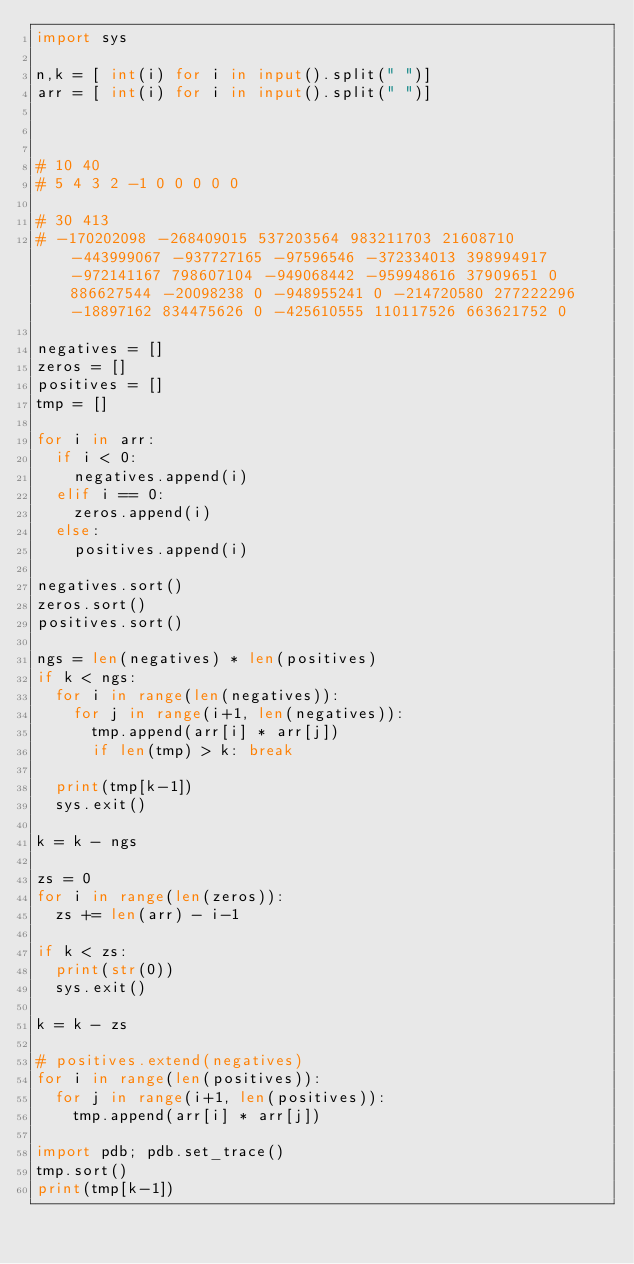Convert code to text. <code><loc_0><loc_0><loc_500><loc_500><_Python_>import sys

n,k = [ int(i) for i in input().split(" ")]
arr = [ int(i) for i in input().split(" ")]



# 10 40
# 5 4 3 2 -1 0 0 0 0 0

# 30 413
# -170202098 -268409015 537203564 983211703 21608710 -443999067 -937727165 -97596546 -372334013 398994917 -972141167 798607104 -949068442 -959948616 37909651 0 886627544 -20098238 0 -948955241 0 -214720580 277222296 -18897162 834475626 0 -425610555 110117526 663621752 0

negatives = []
zeros = []
positives = []
tmp = []

for i in arr:
  if i < 0:
    negatives.append(i)
  elif i == 0:
    zeros.append(i)
  else:
    positives.append(i)

negatives.sort()
zeros.sort()
positives.sort()

ngs = len(negatives) * len(positives)
if k < ngs:
  for i in range(len(negatives)):
    for j in range(i+1, len(negatives)):
      tmp.append(arr[i] * arr[j])
      if len(tmp) > k: break

  print(tmp[k-1])
  sys.exit()

k = k - ngs

zs = 0
for i in range(len(zeros)):
  zs += len(arr) - i-1

if k < zs:
  print(str(0))
  sys.exit()

k = k - zs

# positives.extend(negatives)
for i in range(len(positives)):
  for j in range(i+1, len(positives)):
    tmp.append(arr[i] * arr[j])

import pdb; pdb.set_trace()
tmp.sort()
print(tmp[k-1])</code> 